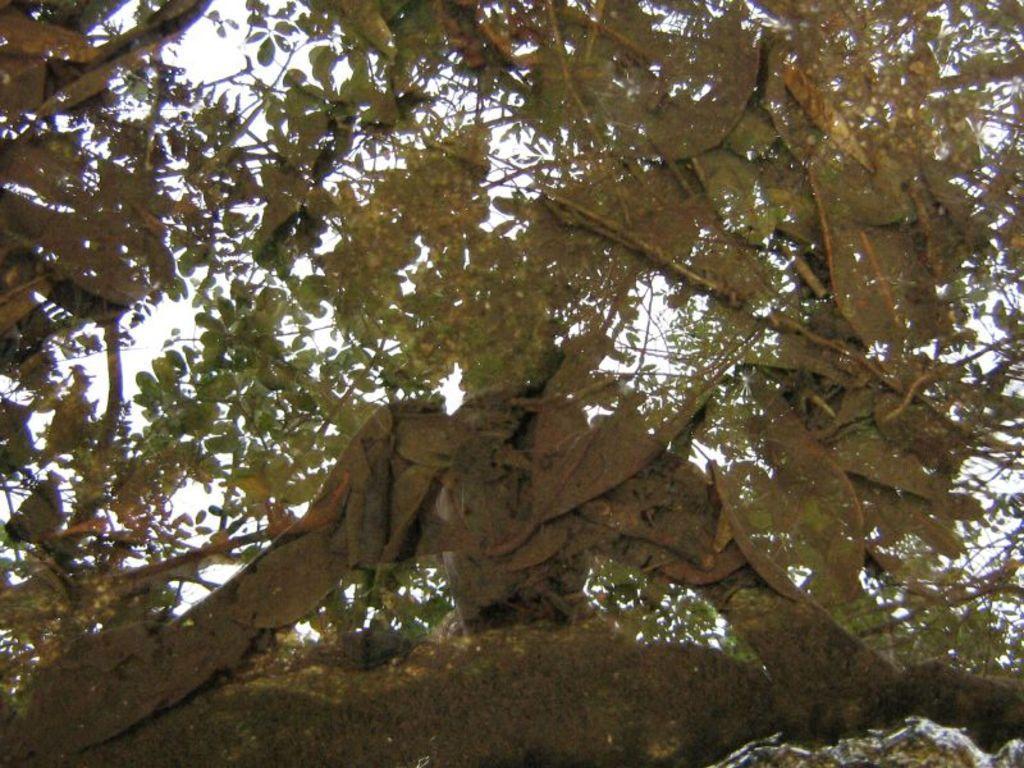Describe this image in one or two sentences. In this picture we can observe a tree with number of branches. In the background there is a sky. 